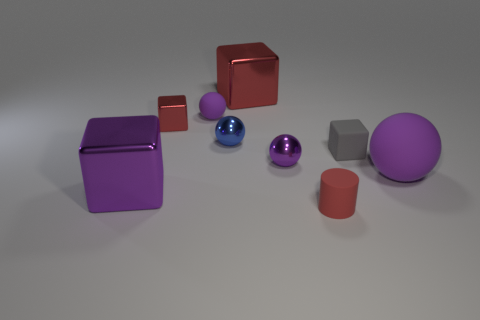Subtract all shiny blocks. How many blocks are left? 1 Subtract 1 cylinders. How many cylinders are left? 0 Subtract all purple cylinders. How many green cubes are left? 0 Subtract all tiny blue objects. Subtract all big red blocks. How many objects are left? 7 Add 3 small red matte cylinders. How many small red matte cylinders are left? 4 Add 7 big blue matte cylinders. How many big blue matte cylinders exist? 7 Subtract all blue spheres. How many spheres are left? 3 Subtract 1 purple cubes. How many objects are left? 8 Subtract all balls. How many objects are left? 5 Subtract all blue spheres. Subtract all purple cubes. How many spheres are left? 3 